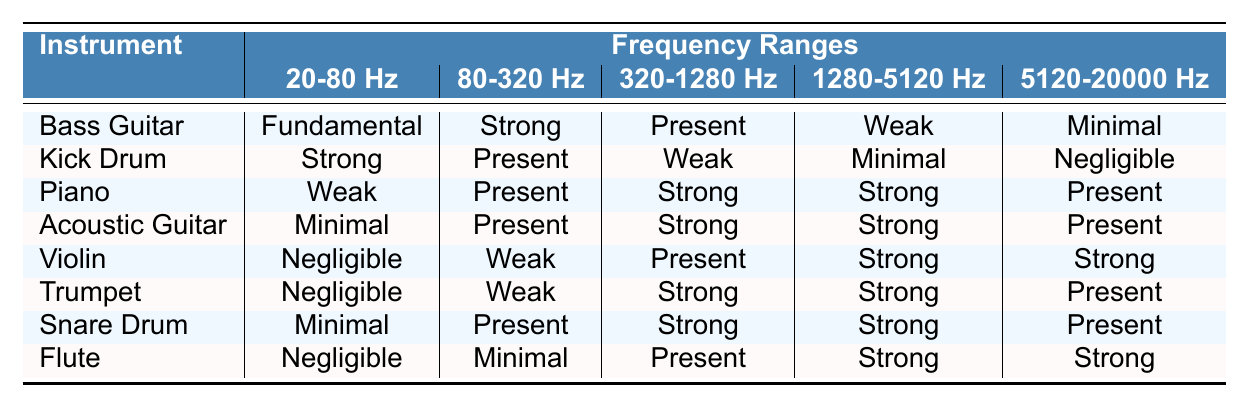What instrument has the strongest presence in the 20-80 Hz range? Looking at the "20-80 Hz" column, the "Kick Drum" is noted as "Strong," while other instruments like "Bass Guitar" and "Piano" have lower designations. Therefore, the "Kick Drum" is the instrument with the strongest presence in this frequency range.
Answer: Kick Drum Which instruments show a 'Strong' presence in the 320-1280 Hz range? In the "320-1280 Hz" column, the instruments that have a "Strong" presence are the "Piano," "Acoustic Guitar," "Trumpet," and "Snare Drum." By checking the respective rows, we can identify these four instruments.
Answer: Piano, Acoustic Guitar, Trumpet, Snare Drum Is the "Bass Guitar" effective in the 5120-20000 Hz range? The "Bass Guitar" rating in the "5120-20000 Hz" column is "Minimal." Since this indicates a very low presence, the answer is no, it is not effective in this range.
Answer: No What is the difference in presence strength between "Piano" and "Violin" in the 1280-5120 Hz range? The "Piano" is rated "Strong," while the "Violin" is also rated "Strong" in the "1280-5120 Hz" column, resulting in no difference.
Answer: 0 Which instrument has minimal presence across all frequency ranges? To find this, we check each instrument's ratings across all frequency ranges. The "Flute" has "Negligible," "Minimal," and "Present," but no "Weak" or "Strong," indicating overall minimal effectiveness.
Answer: Flute Are any instruments equally strong in the 80-320 Hz and 1280-5120 Hz ranges? By comparing the columns, both "Piano" and "Snare Drum" have "Present" in 80-320 Hz and "Strong" in 1280-5120 Hz, but no single instrument is rated the same in both ranges based on the available data.
Answer: No Which category of instruments is most prevalent in the frequency range of 320-1280 Hz? The "Piano," "Acoustic Guitar," "Trumpet," and "Snare Drum" all exhibit a "Strong" presence in this range, indicating that a variety of instruments fall within the Mid category.
Answer: Mid If we combine the presence ratings of "Acoustic Guitar" in both 320-1280 Hz and 1280-5120 Hz, what is the overall presence classification? The "Acoustic Guitar" has "Strong" in both the 320-1280 Hz and 1280-5120 Hz ranges. If we consider this as a combined effect, it remains "Strong."
Answer: Strong What percentage of instruments are classified as "Negligible" in the 20-80 Hz range? There are 8 instruments in total; "Violin," "Trumpet," and "Flute" are rated as "Negligible." That’s 3 out of 8, which calculates to 37.5%, or about 38% when rounded.
Answer: 38% Which two instruments have a similar presence in the 80-320 Hz range? In the "80-320 Hz" column, both "Piano" and "Kick Drum" have "Present." We can see that they have the same presence level, making them similar in this frequency range.
Answer: Piano, Kick Drum 